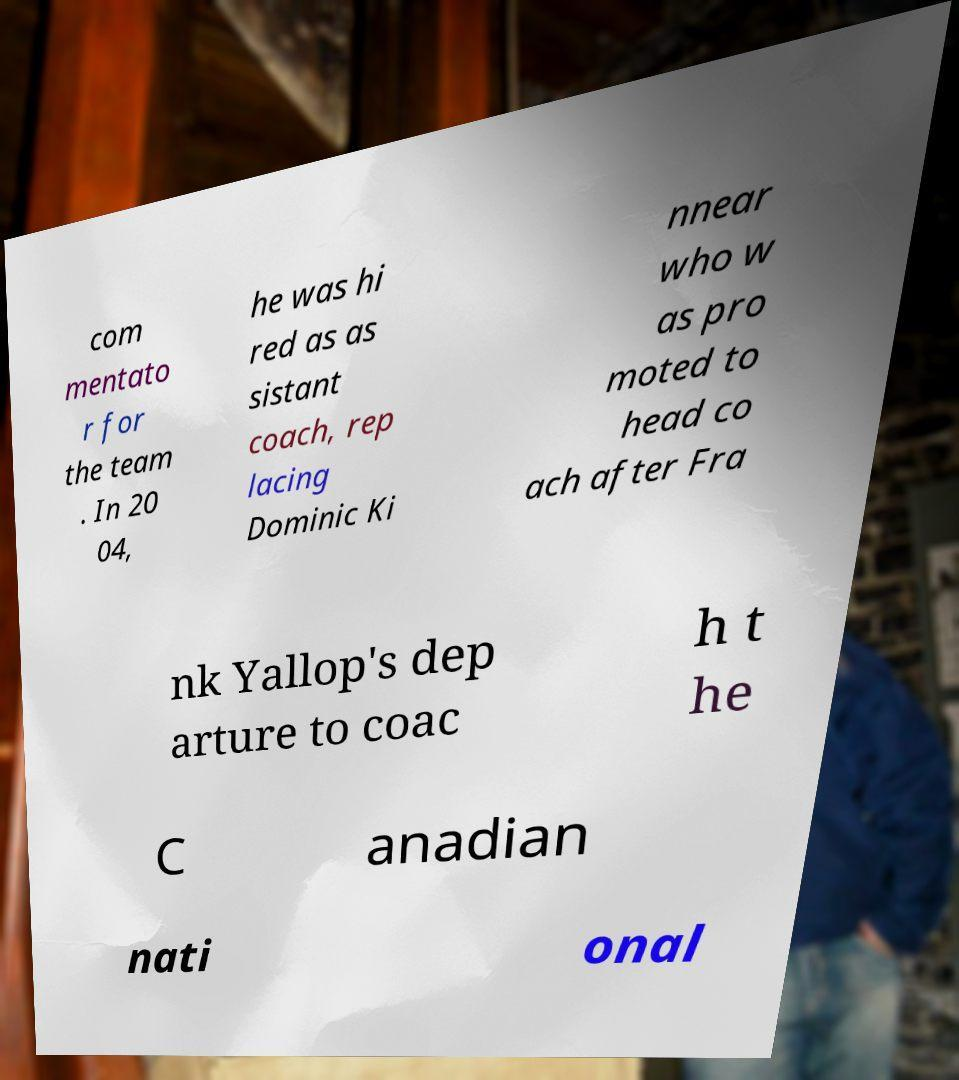What messages or text are displayed in this image? I need them in a readable, typed format. com mentato r for the team . In 20 04, he was hi red as as sistant coach, rep lacing Dominic Ki nnear who w as pro moted to head co ach after Fra nk Yallop's dep arture to coac h t he C anadian nati onal 